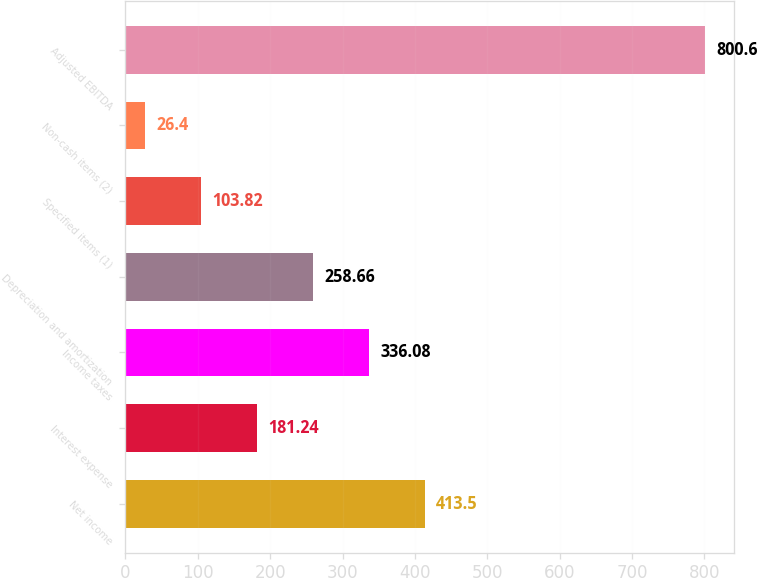<chart> <loc_0><loc_0><loc_500><loc_500><bar_chart><fcel>Net income<fcel>Interest expense<fcel>Income taxes<fcel>Depreciation and amortization<fcel>Specified items (1)<fcel>Non-cash items (2)<fcel>Adjusted EBITDA<nl><fcel>413.5<fcel>181.24<fcel>336.08<fcel>258.66<fcel>103.82<fcel>26.4<fcel>800.6<nl></chart> 